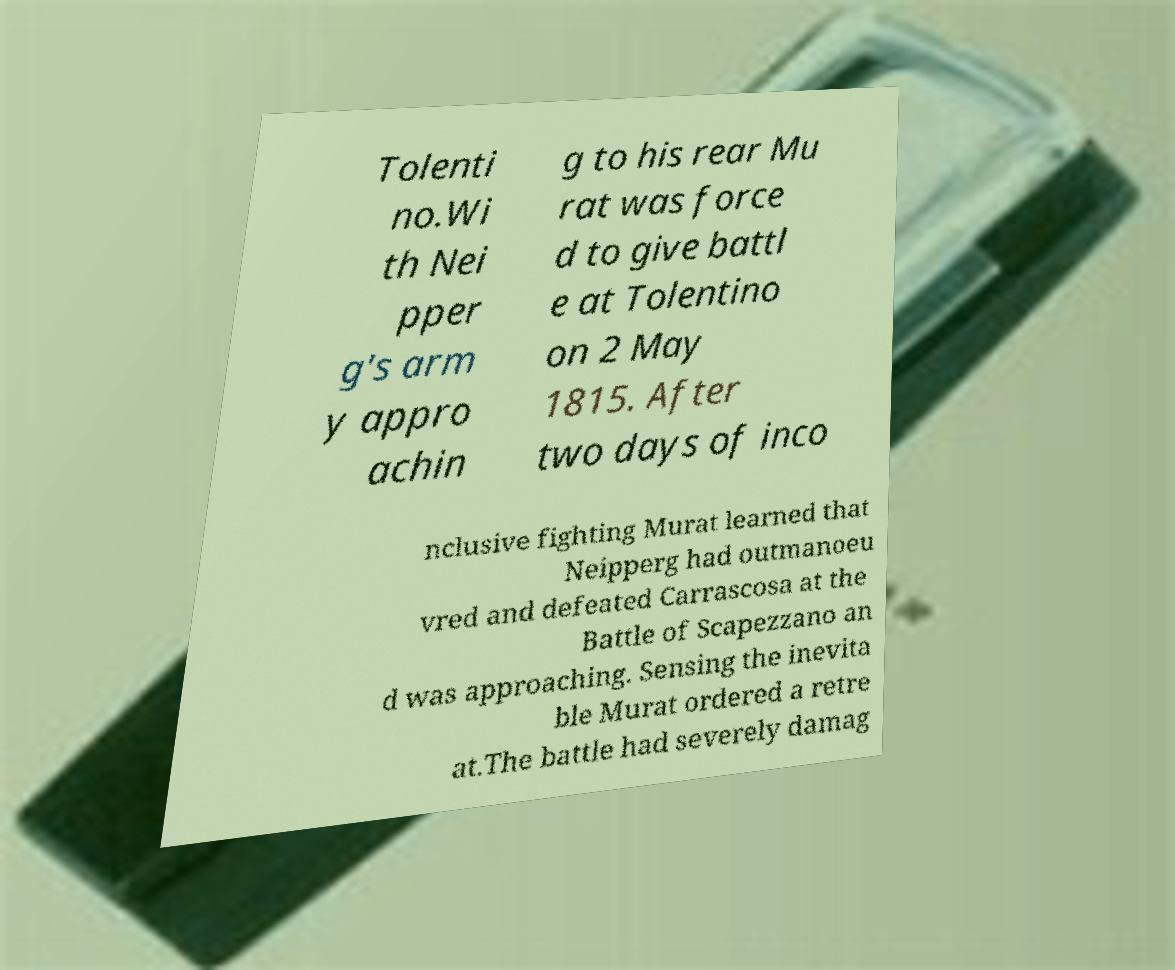For documentation purposes, I need the text within this image transcribed. Could you provide that? Tolenti no.Wi th Nei pper g's arm y appro achin g to his rear Mu rat was force d to give battl e at Tolentino on 2 May 1815. After two days of inco nclusive fighting Murat learned that Neipperg had outmanoeu vred and defeated Carrascosa at the Battle of Scapezzano an d was approaching. Sensing the inevita ble Murat ordered a retre at.The battle had severely damag 